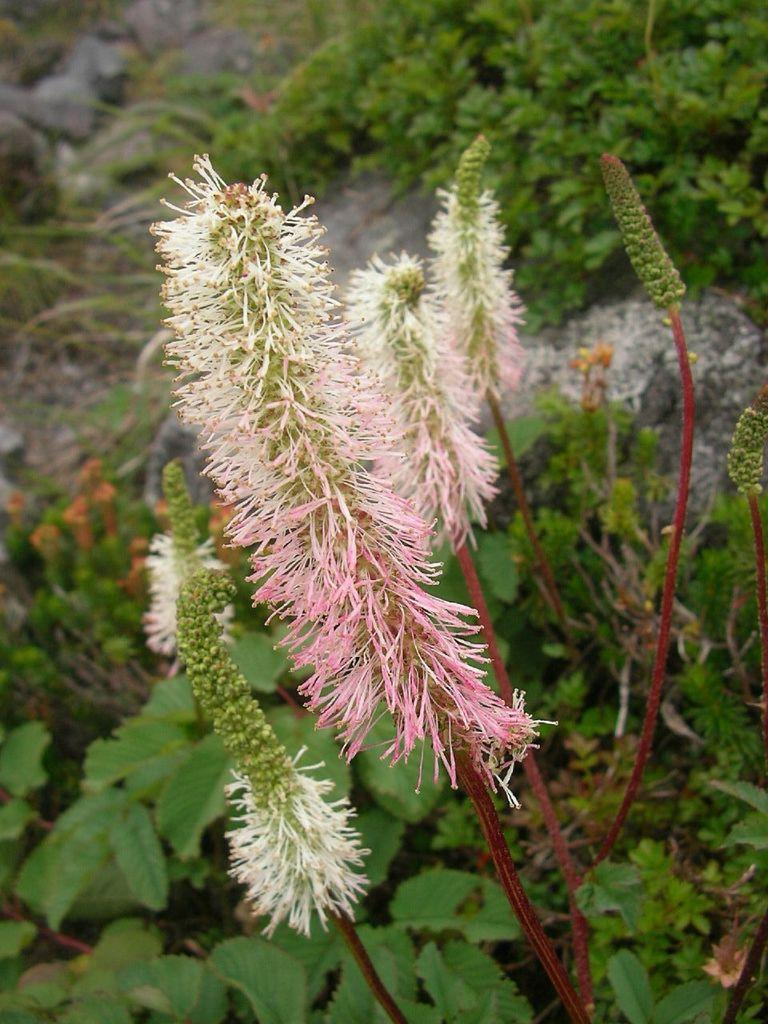What type of natural elements can be seen in the image? There are plants and rocks in the image. Where are the plants and rocks located? The plants and rocks are on a path. Can you describe the path in the image? The path is where the plants and rocks are located. What type of music is the band playing in the image? There is no band present in the image, so it is not possible to determine what type of music they might be playing. 